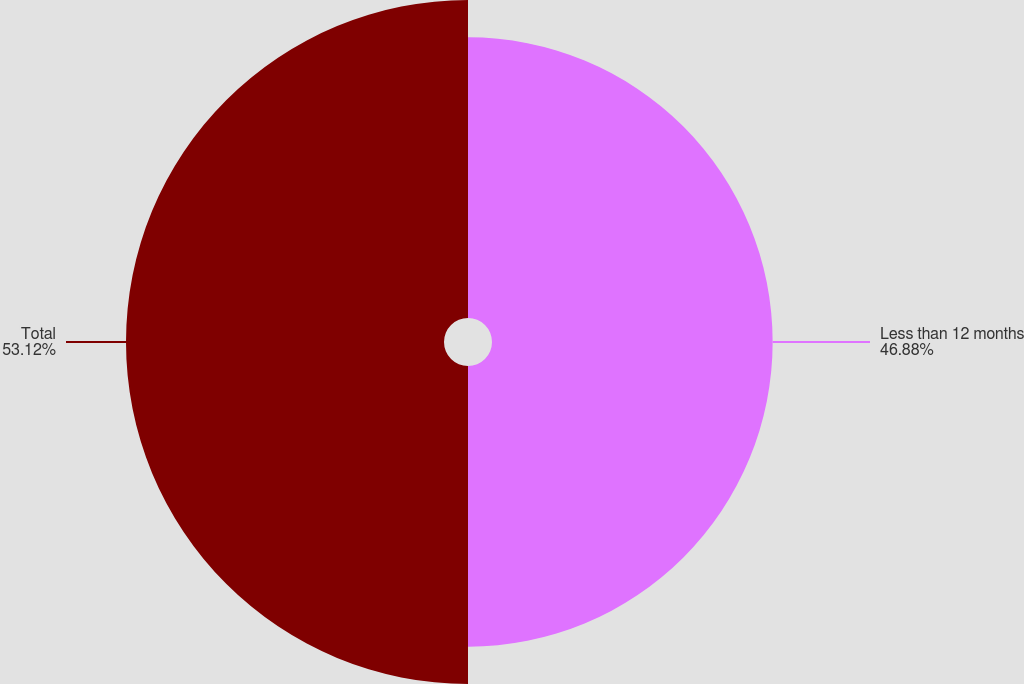Convert chart to OTSL. <chart><loc_0><loc_0><loc_500><loc_500><pie_chart><fcel>Less than 12 months<fcel>Total<nl><fcel>46.88%<fcel>53.12%<nl></chart> 